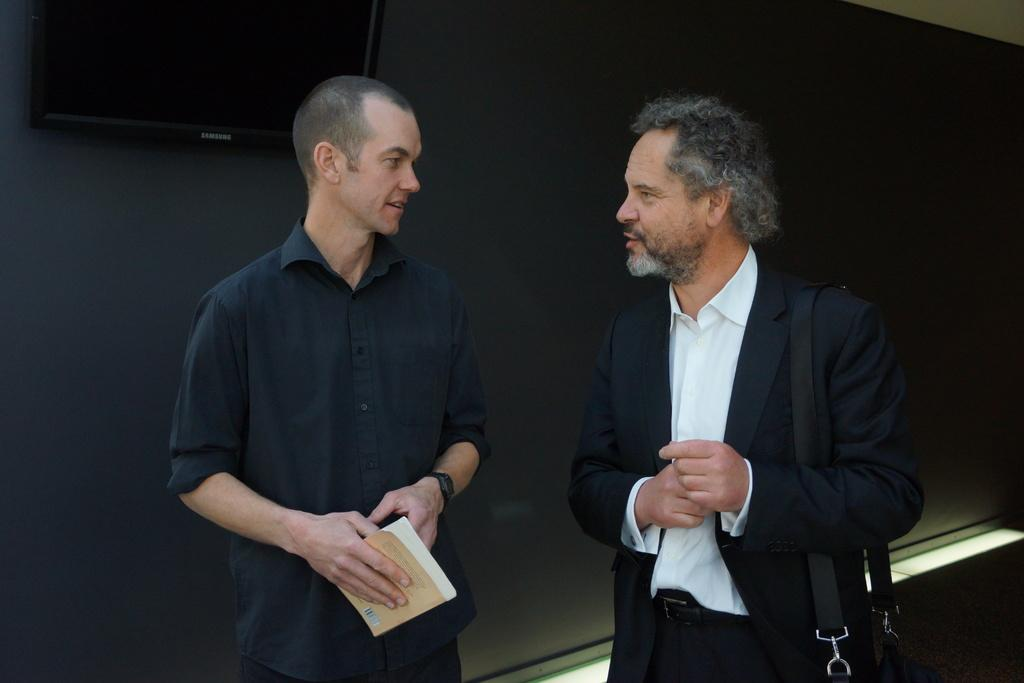How many people are present in the image? There are two men standing in the image. What is one of the men holding? One man is holding a book. What can be seen on the wall behind the men? There is a television on the wall behind the men. What type of territory is being claimed by the flesh in the image? There is no territory or flesh present in the image. 